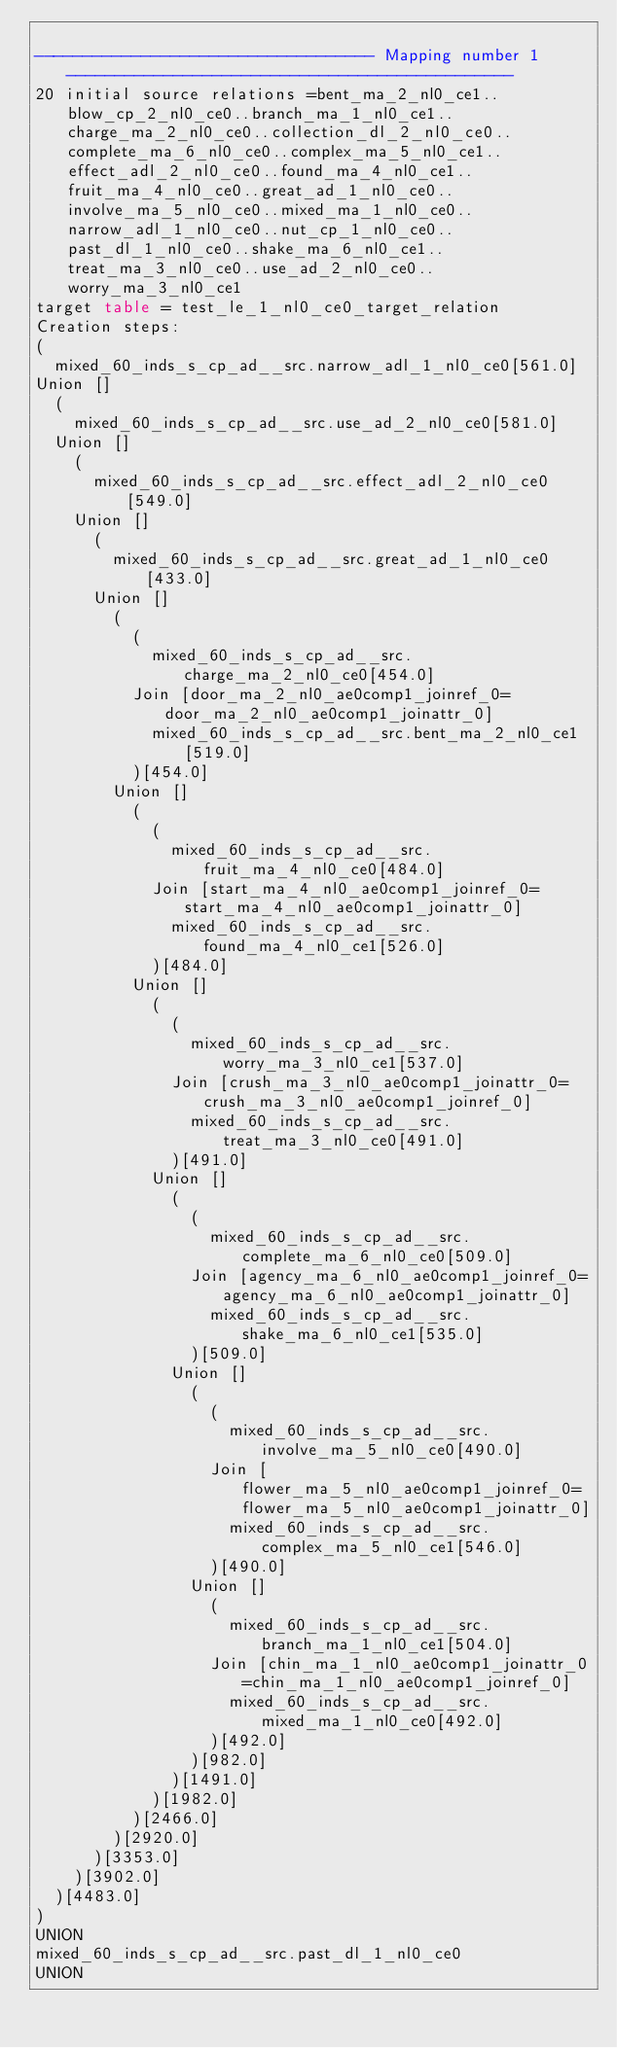Convert code to text. <code><loc_0><loc_0><loc_500><loc_500><_SQL_>
----------------------------------- Mapping number 1 ----------------------------------------------
20 initial source relations =bent_ma_2_nl0_ce1..blow_cp_2_nl0_ce0..branch_ma_1_nl0_ce1..charge_ma_2_nl0_ce0..collection_dl_2_nl0_ce0..complete_ma_6_nl0_ce0..complex_ma_5_nl0_ce1..effect_adl_2_nl0_ce0..found_ma_4_nl0_ce1..fruit_ma_4_nl0_ce0..great_ad_1_nl0_ce0..involve_ma_5_nl0_ce0..mixed_ma_1_nl0_ce0..narrow_adl_1_nl0_ce0..nut_cp_1_nl0_ce0..past_dl_1_nl0_ce0..shake_ma_6_nl0_ce1..treat_ma_3_nl0_ce0..use_ad_2_nl0_ce0..worry_ma_3_nl0_ce1
target table = test_le_1_nl0_ce0_target_relation
Creation steps:
(
	mixed_60_inds_s_cp_ad__src.narrow_adl_1_nl0_ce0[561.0]
Union []
	(
		mixed_60_inds_s_cp_ad__src.use_ad_2_nl0_ce0[581.0]
	Union []
		(
			mixed_60_inds_s_cp_ad__src.effect_adl_2_nl0_ce0[549.0]
		Union []
			(
				mixed_60_inds_s_cp_ad__src.great_ad_1_nl0_ce0[433.0]
			Union []
				(
					(
						mixed_60_inds_s_cp_ad__src.charge_ma_2_nl0_ce0[454.0]
					Join [door_ma_2_nl0_ae0comp1_joinref_0=door_ma_2_nl0_ae0comp1_joinattr_0]
						mixed_60_inds_s_cp_ad__src.bent_ma_2_nl0_ce1[519.0]
					)[454.0]
				Union []
					(
						(
							mixed_60_inds_s_cp_ad__src.fruit_ma_4_nl0_ce0[484.0]
						Join [start_ma_4_nl0_ae0comp1_joinref_0=start_ma_4_nl0_ae0comp1_joinattr_0]
							mixed_60_inds_s_cp_ad__src.found_ma_4_nl0_ce1[526.0]
						)[484.0]
					Union []
						(
							(
								mixed_60_inds_s_cp_ad__src.worry_ma_3_nl0_ce1[537.0]
							Join [crush_ma_3_nl0_ae0comp1_joinattr_0=crush_ma_3_nl0_ae0comp1_joinref_0]
								mixed_60_inds_s_cp_ad__src.treat_ma_3_nl0_ce0[491.0]
							)[491.0]
						Union []
							(
								(
									mixed_60_inds_s_cp_ad__src.complete_ma_6_nl0_ce0[509.0]
								Join [agency_ma_6_nl0_ae0comp1_joinref_0=agency_ma_6_nl0_ae0comp1_joinattr_0]
									mixed_60_inds_s_cp_ad__src.shake_ma_6_nl0_ce1[535.0]
								)[509.0]
							Union []
								(
									(
										mixed_60_inds_s_cp_ad__src.involve_ma_5_nl0_ce0[490.0]
									Join [flower_ma_5_nl0_ae0comp1_joinref_0=flower_ma_5_nl0_ae0comp1_joinattr_0]
										mixed_60_inds_s_cp_ad__src.complex_ma_5_nl0_ce1[546.0]
									)[490.0]
								Union []
									(
										mixed_60_inds_s_cp_ad__src.branch_ma_1_nl0_ce1[504.0]
									Join [chin_ma_1_nl0_ae0comp1_joinattr_0=chin_ma_1_nl0_ae0comp1_joinref_0]
										mixed_60_inds_s_cp_ad__src.mixed_ma_1_nl0_ce0[492.0]
									)[492.0]
								)[982.0]
							)[1491.0]
						)[1982.0]
					)[2466.0]
				)[2920.0]
			)[3353.0]
		)[3902.0]
	)[4483.0]
)
UNION
mixed_60_inds_s_cp_ad__src.past_dl_1_nl0_ce0
UNION</code> 